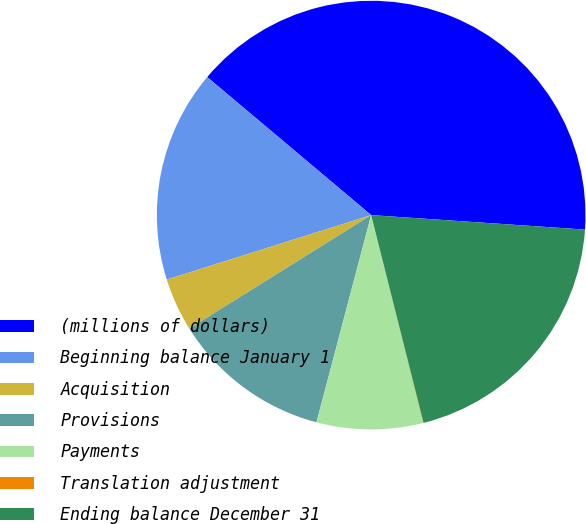Convert chart. <chart><loc_0><loc_0><loc_500><loc_500><pie_chart><fcel>(millions of dollars)<fcel>Beginning balance January 1<fcel>Acquisition<fcel>Provisions<fcel>Payments<fcel>Translation adjustment<fcel>Ending balance December 31<nl><fcel>39.94%<fcel>16.0%<fcel>4.02%<fcel>12.01%<fcel>8.01%<fcel>0.03%<fcel>19.99%<nl></chart> 